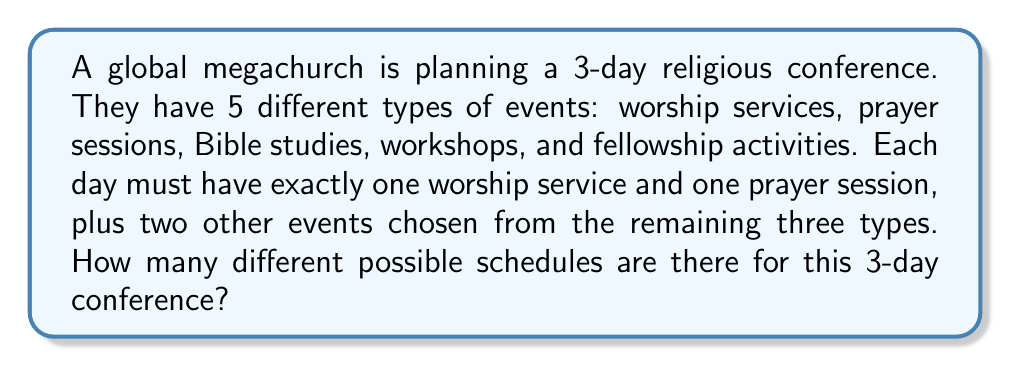Provide a solution to this math problem. Let's break this down step-by-step:

1) For each day, we need to choose:
   - The order of the worship service and prayer session
   - 2 events from the remaining 3 types

2) For a single day:
   - There are 2! = 2 ways to order the worship service and prayer session
   - There are $\binom{3}{2} = 3$ ways to choose 2 events from the remaining 3 types
   - There are 2! = 2 ways to order these 2 chosen events

3) So, for a single day, there are:
   $2 \times 3 \times 2 = 12$ possible schedules

4) The conference lasts for 3 days, and each day's schedule is independent of the others

5) Therefore, we can use the multiplication principle:
   Total number of schedules = $12^3 = 1,728$
Answer: 1,728 